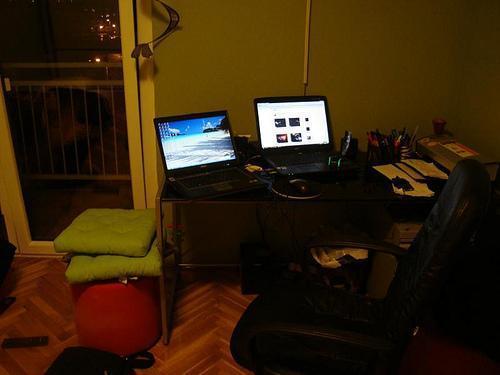How many backpacks are visible?
Give a very brief answer. 1. How many laptops are in the picture?
Give a very brief answer. 2. How many red cars are there?
Give a very brief answer. 0. 